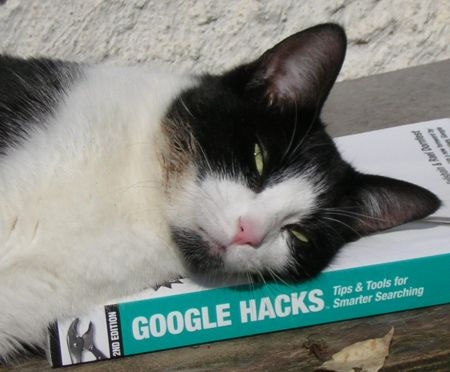Describe the objects in this image and their specific colors. I can see cat in black, darkgray, lightgray, and gray tones and book in black, lightgray, teal, lightblue, and darkgray tones in this image. 